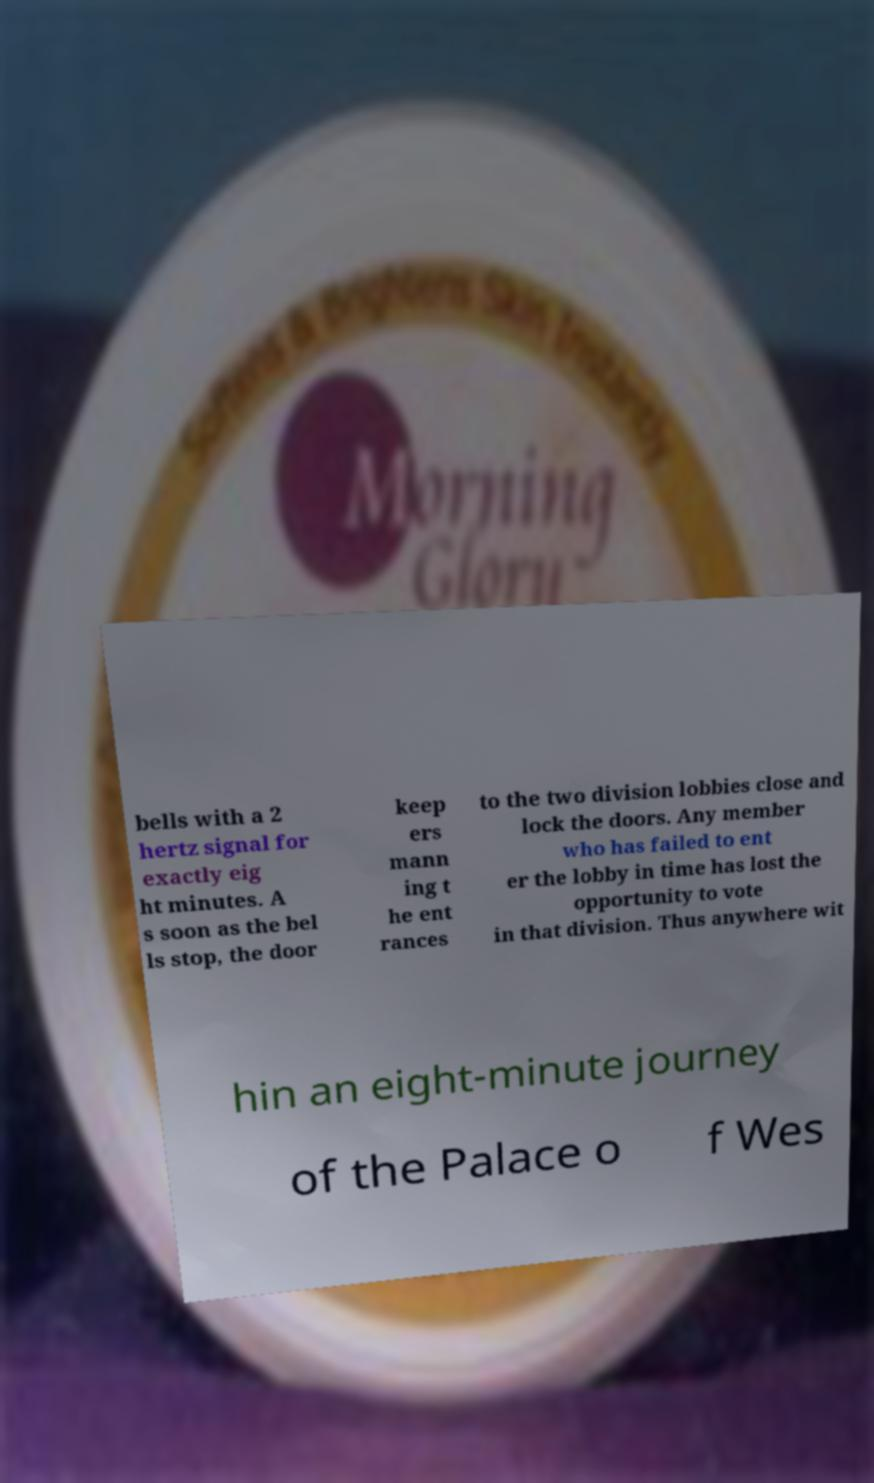Please identify and transcribe the text found in this image. bells with a 2 hertz signal for exactly eig ht minutes. A s soon as the bel ls stop, the door keep ers mann ing t he ent rances to the two division lobbies close and lock the doors. Any member who has failed to ent er the lobby in time has lost the opportunity to vote in that division. Thus anywhere wit hin an eight-minute journey of the Palace o f Wes 